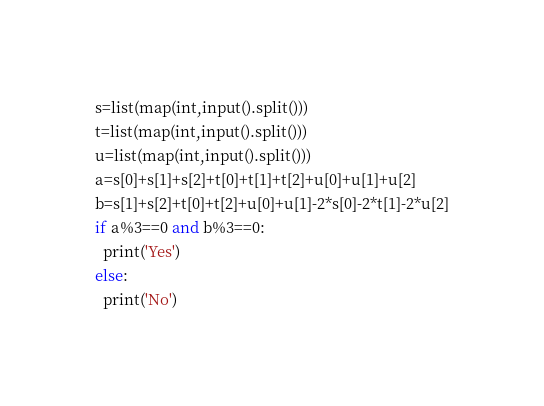Convert code to text. <code><loc_0><loc_0><loc_500><loc_500><_Python_>s=list(map(int,input().split()))
t=list(map(int,input().split()))
u=list(map(int,input().split()))
a=s[0]+s[1]+s[2]+t[0]+t[1]+t[2]+u[0]+u[1]+u[2]
b=s[1]+s[2]+t[0]+t[2]+u[0]+u[1]-2*s[0]-2*t[1]-2*u[2]
if a%3==0 and b%3==0:
  print('Yes')
else:
  print('No')</code> 